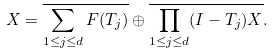<formula> <loc_0><loc_0><loc_500><loc_500>X = \overline { \sum _ { 1 \leq j \leq d } F ( T _ { j } ) } \oplus \overline { \prod _ { 1 \leq j \leq d } ( I - T _ { j } ) X } .</formula> 